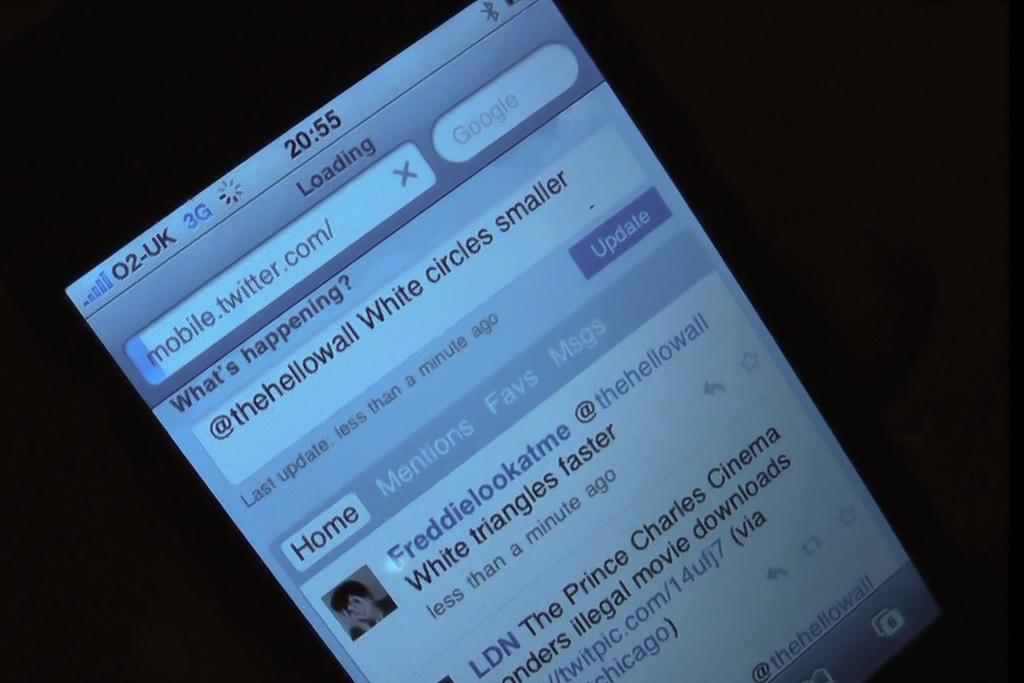What time is on the phone?
Offer a very short reply. 20:55. What is the @ on the post?
Your answer should be very brief. Thehellowall. 